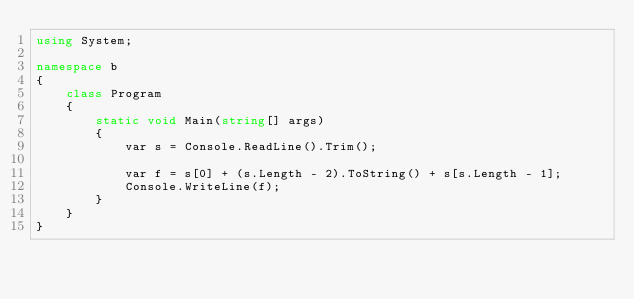Convert code to text. <code><loc_0><loc_0><loc_500><loc_500><_C#_>using System;

namespace b
{
    class Program
    {
        static void Main(string[] args)
        {
            var s = Console.ReadLine().Trim();

            var f = s[0] + (s.Length - 2).ToString() + s[s.Length - 1];
            Console.WriteLine(f);
        }
    }
}
</code> 